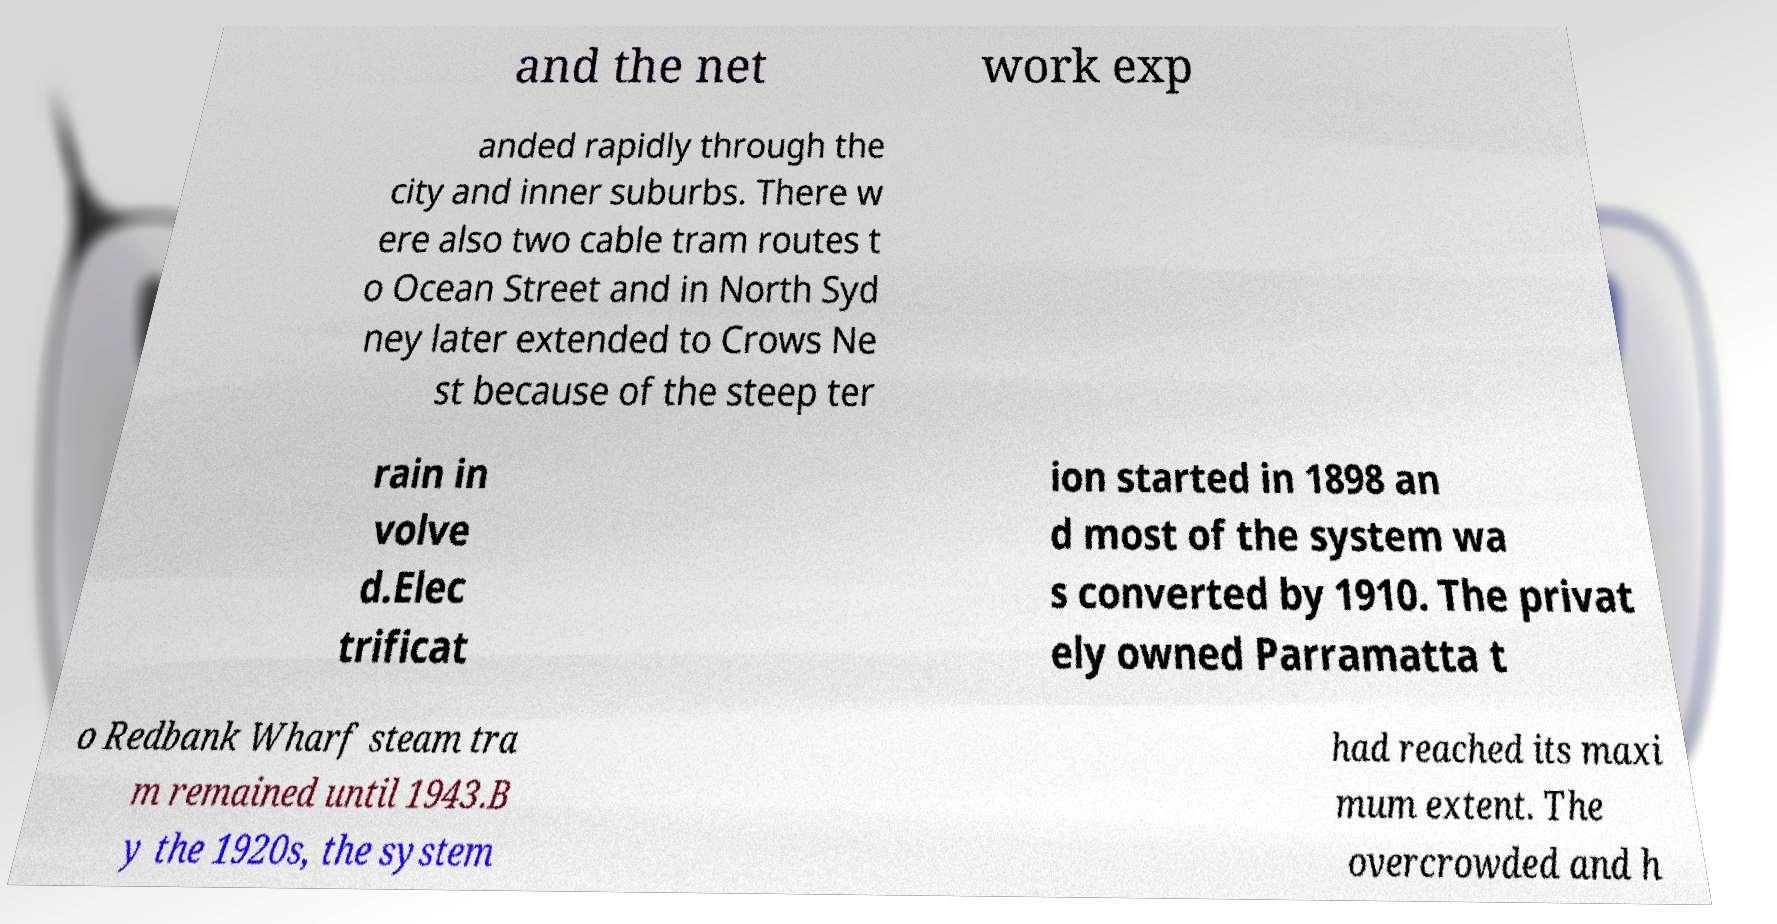Please read and relay the text visible in this image. What does it say? and the net work exp anded rapidly through the city and inner suburbs. There w ere also two cable tram routes t o Ocean Street and in North Syd ney later extended to Crows Ne st because of the steep ter rain in volve d.Elec trificat ion started in 1898 an d most of the system wa s converted by 1910. The privat ely owned Parramatta t o Redbank Wharf steam tra m remained until 1943.B y the 1920s, the system had reached its maxi mum extent. The overcrowded and h 